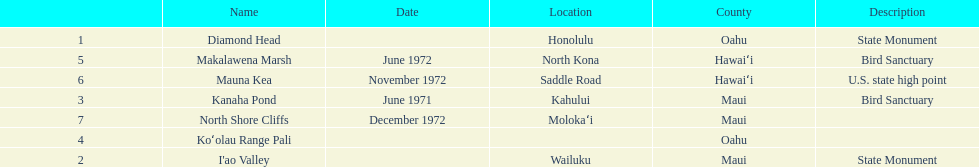Write the full table. {'header': ['', 'Name', 'Date', 'Location', 'County', 'Description'], 'rows': [['1', 'Diamond Head', '', 'Honolulu', 'Oahu', 'State Monument'], ['5', 'Makalawena Marsh', 'June 1972', 'North Kona', 'Hawaiʻi', 'Bird Sanctuary'], ['6', 'Mauna Kea', 'November 1972', 'Saddle Road', 'Hawaiʻi', 'U.S. state high point'], ['3', 'Kanaha Pond', 'June 1971', 'Kahului', 'Maui', 'Bird Sanctuary'], ['7', 'North Shore Cliffs', 'December 1972', 'Molokaʻi', 'Maui', ''], ['4', 'Koʻolau Range Pali', '', '', 'Oahu', ''], ['2', "I'ao Valley", '', 'Wailuku', 'Maui', 'State Monument']]} How many dates are in 1972? 3. 